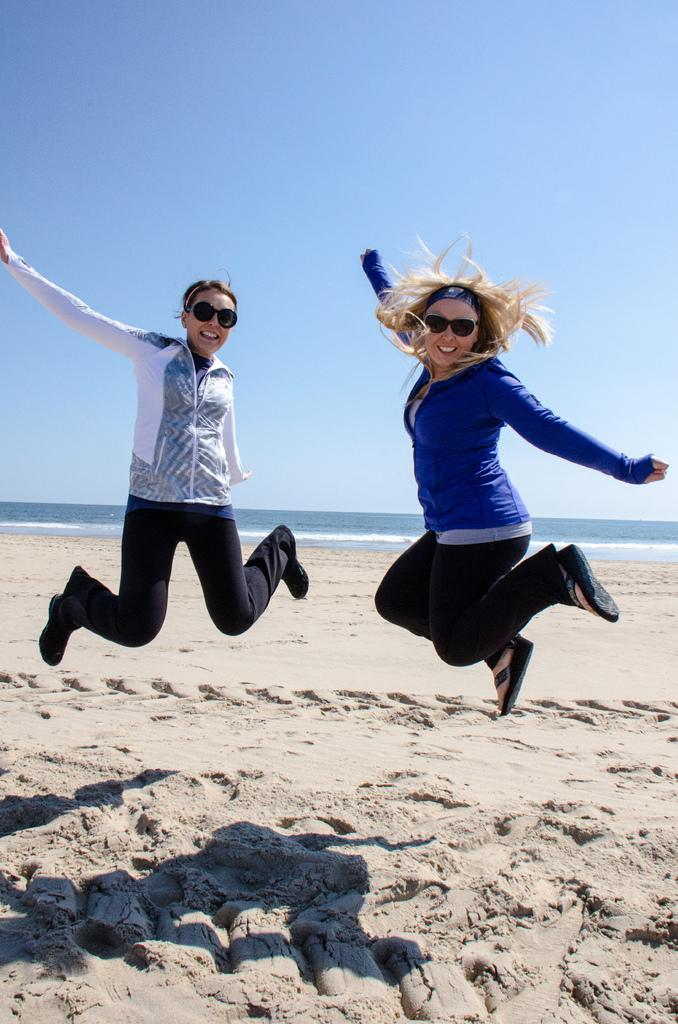How many people are in the image? There are two women in the image. What are the women doing in the image? The women are jumping in the air. What type of surface is beneath the women? There is sand on the ground. What is the emotional expression of the women? The women are smiling. What can be seen in the distance behind the women? There is water visible in the background. What is visible at the top of the image? The sky is visible at the top of the image. Are the women sleeping in beds in the image? No, the women are not sleeping in beds in the image; they are jumping in the air. What type of cast can be seen on the women's arms in the image? There is no cast present on the women's arms in the image. 